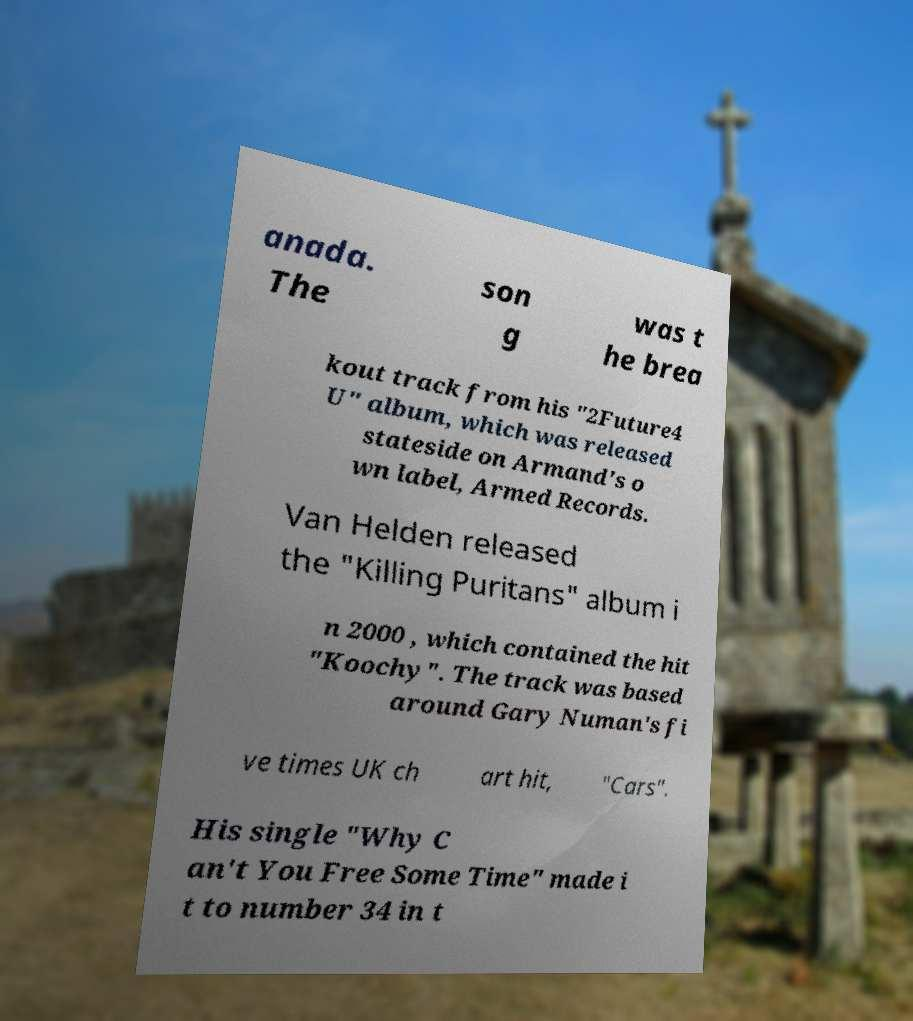There's text embedded in this image that I need extracted. Can you transcribe it verbatim? anada. The son g was t he brea kout track from his "2Future4 U" album, which was released stateside on Armand's o wn label, Armed Records. Van Helden released the "Killing Puritans" album i n 2000 , which contained the hit "Koochy". The track was based around Gary Numan's fi ve times UK ch art hit, "Cars". His single "Why C an't You Free Some Time" made i t to number 34 in t 